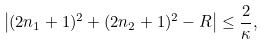<formula> <loc_0><loc_0><loc_500><loc_500>\left | ( 2 n _ { 1 } + 1 ) ^ { 2 } + ( 2 n _ { 2 } + 1 ) ^ { 2 } - R \right | \leq \frac { 2 } { \kappa } ,</formula> 